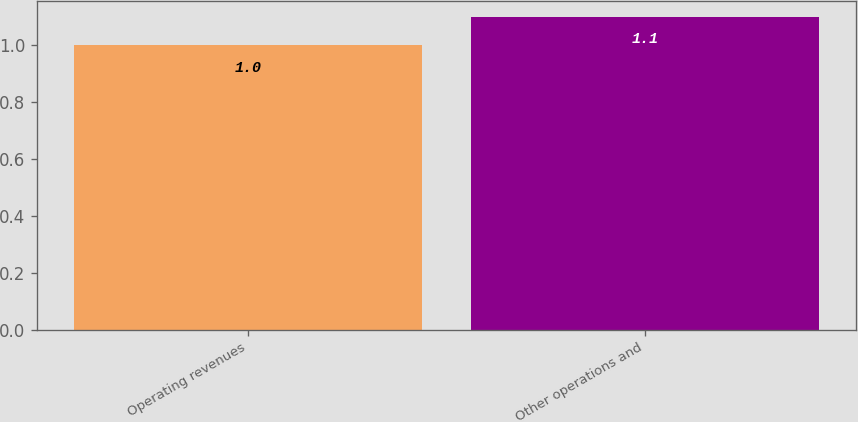Convert chart. <chart><loc_0><loc_0><loc_500><loc_500><bar_chart><fcel>Operating revenues<fcel>Other operations and<nl><fcel>1<fcel>1.1<nl></chart> 